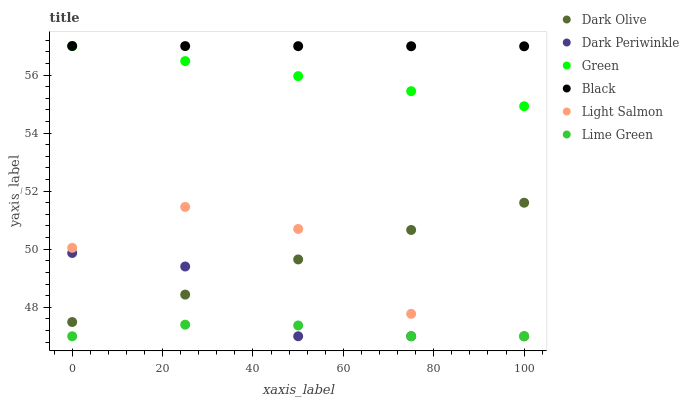Does Lime Green have the minimum area under the curve?
Answer yes or no. Yes. Does Black have the maximum area under the curve?
Answer yes or no. Yes. Does Dark Olive have the minimum area under the curve?
Answer yes or no. No. Does Dark Olive have the maximum area under the curve?
Answer yes or no. No. Is Green the smoothest?
Answer yes or no. Yes. Is Light Salmon the roughest?
Answer yes or no. Yes. Is Dark Olive the smoothest?
Answer yes or no. No. Is Dark Olive the roughest?
Answer yes or no. No. Does Light Salmon have the lowest value?
Answer yes or no. Yes. Does Dark Olive have the lowest value?
Answer yes or no. No. Does Green have the highest value?
Answer yes or no. Yes. Does Dark Olive have the highest value?
Answer yes or no. No. Is Dark Olive less than Green?
Answer yes or no. Yes. Is Black greater than Lime Green?
Answer yes or no. Yes. Does Green intersect Black?
Answer yes or no. Yes. Is Green less than Black?
Answer yes or no. No. Is Green greater than Black?
Answer yes or no. No. Does Dark Olive intersect Green?
Answer yes or no. No. 